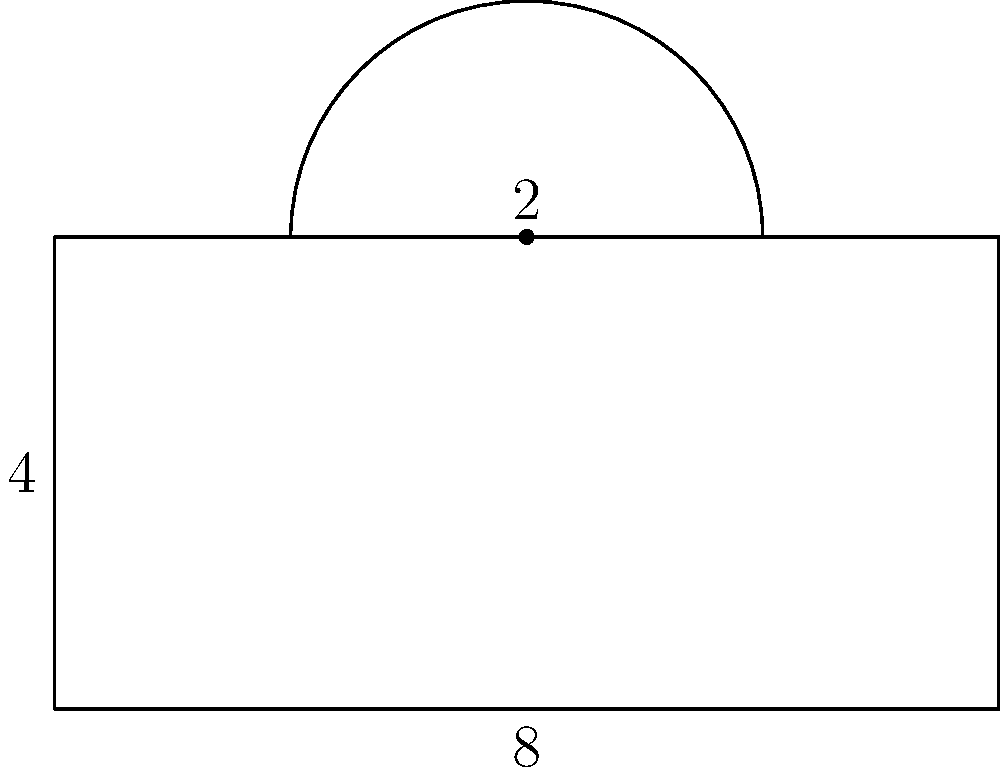After debugging a complex Java application, you decide to take a break and solve a geometry problem. Consider the composite shape above, consisting of a rectangle with a semicircle on top. If the rectangle has a width of 8 units and a height of 4 units, and the semicircle has a radius of 2 units, what is the total area of the shape? Round your answer to two decimal places. Let's break this down step-by-step, much like debugging a Java program:

1. Area of the rectangle:
   $A_r = width * height = 8 * 4 = 32$ square units

2. Area of the semicircle:
   Full circle area: $A_c = \pi r^2 = \pi * 2^2 = 4\pi$
   Semicircle area: $A_s = \frac{1}{2} * 4\pi = 2\pi$ square units

3. Total area:
   $A_{total} = A_r + A_s = 32 + 2\pi$

4. Calculating $2\pi$:
   $2\pi \approx 2 * 3.14159 = 6.28318$

5. Final calculation:
   $A_{total} = 32 + 6.28318 = 38.28318$

6. Rounding to two decimal places:
   $A_{total} \approx 38.28$ square units

Just as we would optimize our Java code for efficiency, we've solved this problem step-by-step to arrive at the final, rounded result.
Answer: $38.28$ square units 